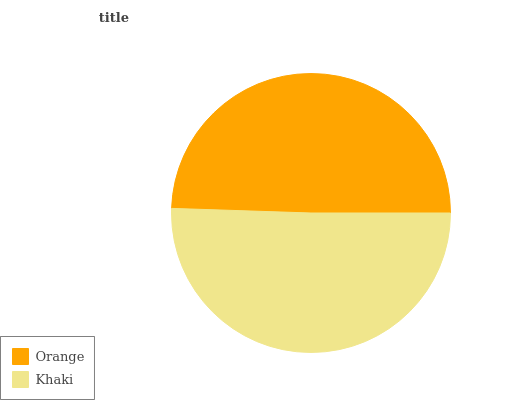Is Orange the minimum?
Answer yes or no. Yes. Is Khaki the maximum?
Answer yes or no. Yes. Is Khaki the minimum?
Answer yes or no. No. Is Khaki greater than Orange?
Answer yes or no. Yes. Is Orange less than Khaki?
Answer yes or no. Yes. Is Orange greater than Khaki?
Answer yes or no. No. Is Khaki less than Orange?
Answer yes or no. No. Is Khaki the high median?
Answer yes or no. Yes. Is Orange the low median?
Answer yes or no. Yes. Is Orange the high median?
Answer yes or no. No. Is Khaki the low median?
Answer yes or no. No. 